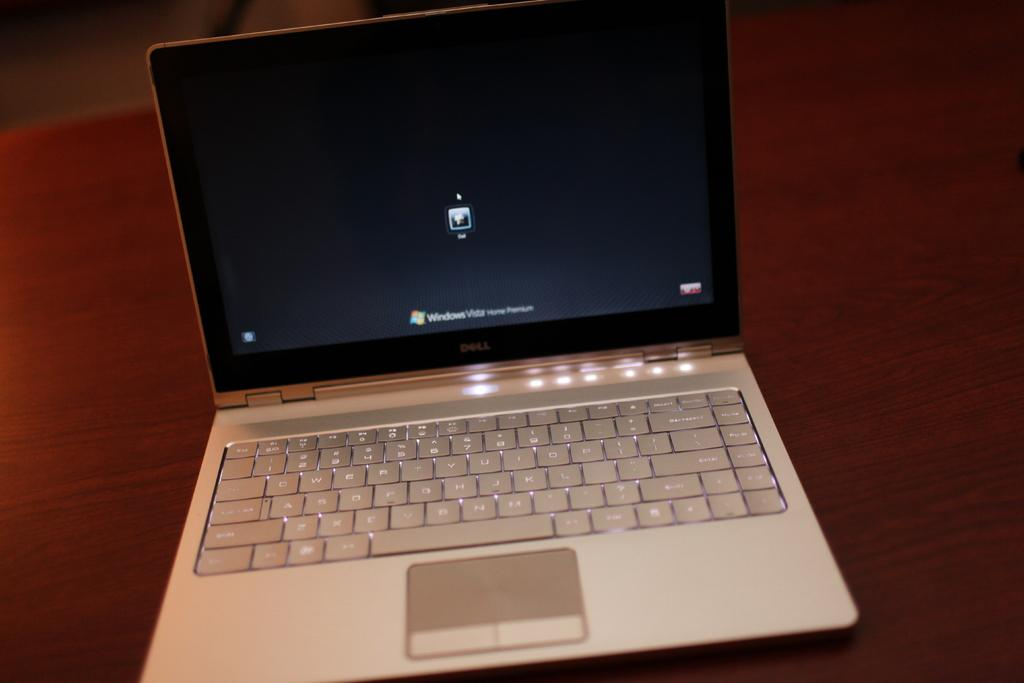<image>
Provide a brief description of the given image. A laptop is on a wooden table and says Windows Vista Home Premium. 